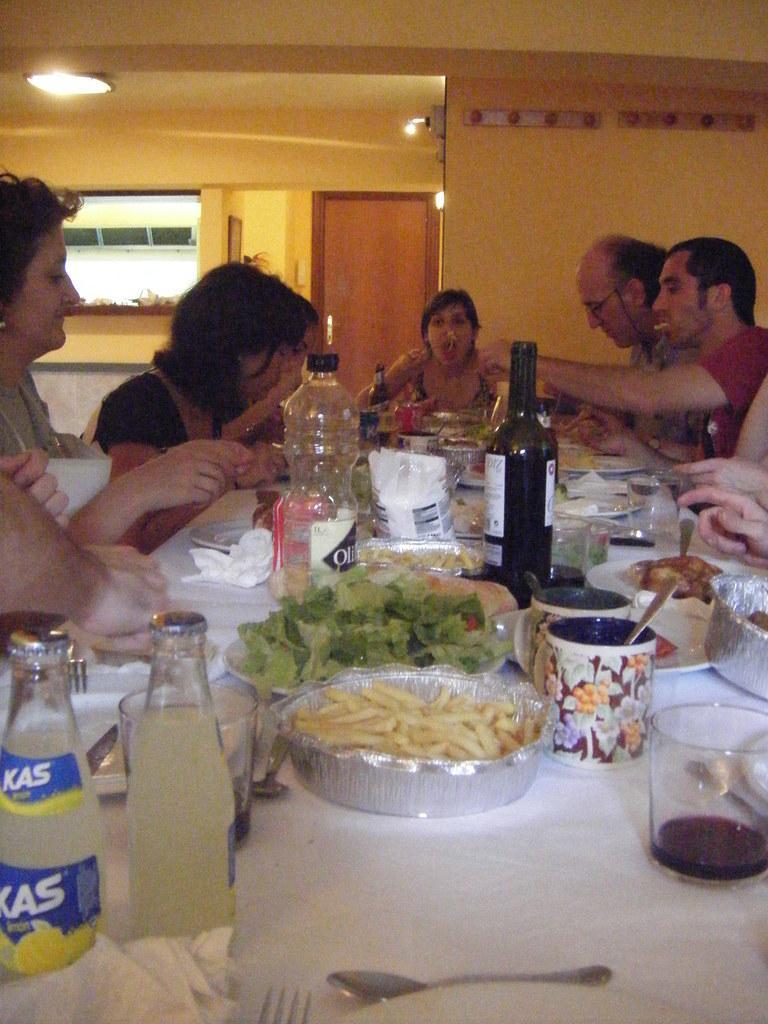Could you give a brief overview of what you see in this image? In this image, There is a table which is in white color on that the are some bottles and glasses and there are some food items on the table, There are some people sitting on the chairs around the table, In the background there is a yellow color and there is a brown color door. 